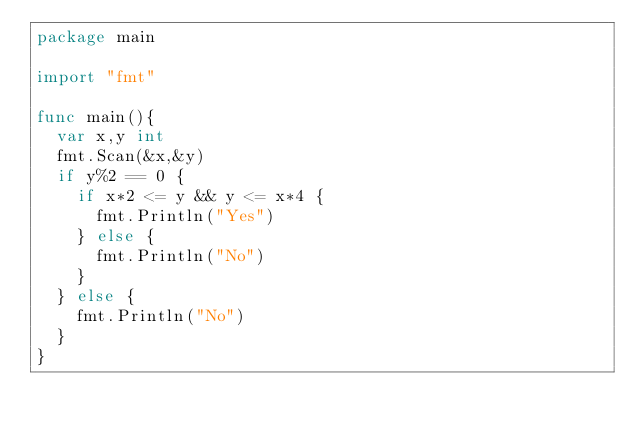Convert code to text. <code><loc_0><loc_0><loc_500><loc_500><_Go_>package main

import "fmt"

func main(){
	var x,y int
	fmt.Scan(&x,&y)
	if y%2 == 0 {
		if x*2 <= y && y <= x*4 {
			fmt.Println("Yes")
		} else {
			fmt.Println("No")
		}
	} else {
		fmt.Println("No")
	}
}
</code> 